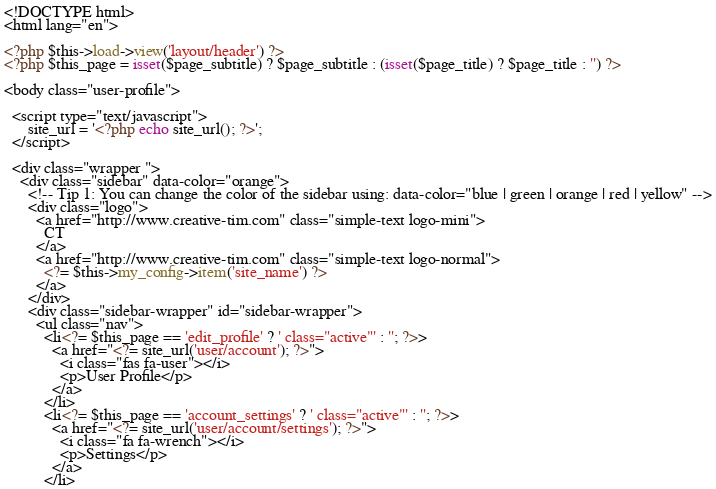<code> <loc_0><loc_0><loc_500><loc_500><_PHP_><!DOCTYPE html>
<html lang="en">

<?php $this->load->view('layout/header') ?>
<?php $this_page = isset($page_subtitle) ? $page_subtitle : (isset($page_title) ? $page_title : '') ?>

<body class="user-profile">

  <script type="text/javascript">
      site_url = '<?php echo site_url(); ?>';
  </script>
        
  <div class="wrapper ">
    <div class="sidebar" data-color="orange">
      <!-- Tip 1: You can change the color of the sidebar using: data-color="blue | green | orange | red | yellow" -->
      <div class="logo">
        <a href="http://www.creative-tim.com" class="simple-text logo-mini">
          CT
        </a>
        <a href="http://www.creative-tim.com" class="simple-text logo-normal">
          <?= $this->my_config->item('site_name') ?>
        </a>
      </div>
      <div class="sidebar-wrapper" id="sidebar-wrapper">
        <ul class="nav">
          <li<?= $this_page == 'edit_profile' ? ' class="active"' : ''; ?>>
            <a href="<?= site_url('user/account'); ?>">
              <i class="fas fa-user"></i>
              <p>User Profile</p>
            </a>
          </li>
          <li<?= $this_page == 'account_settings' ? ' class="active"' : ''; ?>>
            <a href="<?= site_url('user/account/settings'); ?>">
              <i class="fa fa-wrench"></i>
              <p>Settings</p>
            </a>
          </li></code> 